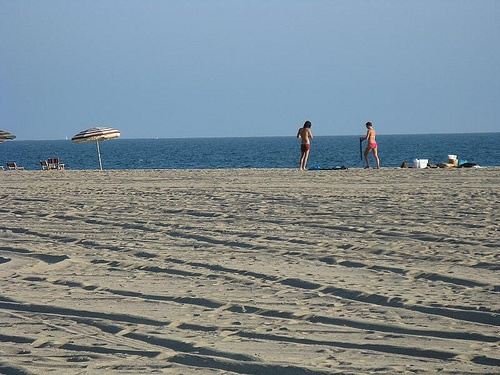Describe the objects in this image and their specific colors. I can see umbrella in darkgray, gray, lightgray, and black tones, people in darkgray, black, maroon, and gray tones, people in darkgray, maroon, black, gray, and tan tones, umbrella in darkgray, gray, and black tones, and chair in darkgray, gray, black, and blue tones in this image. 